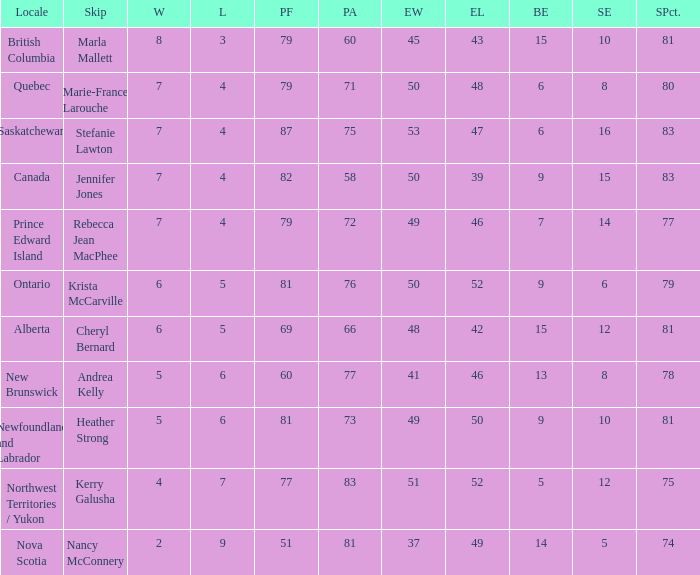What is the total of blank ends at Prince Edward Island? 7.0. 